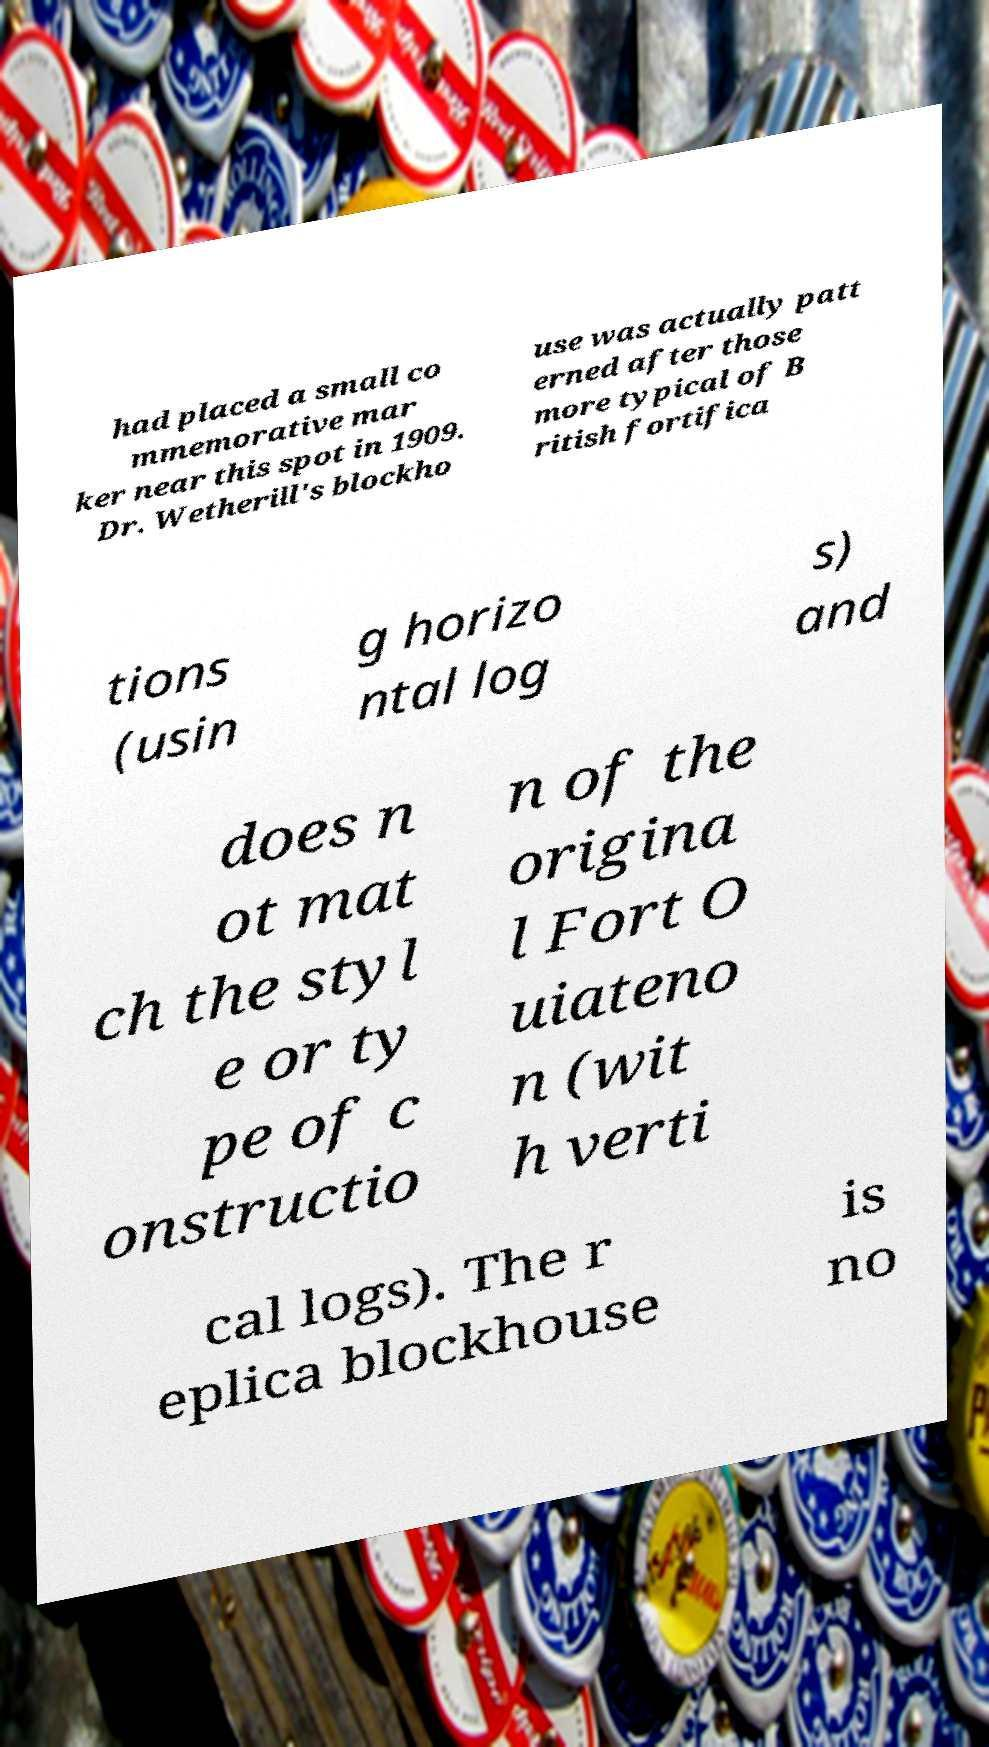Can you accurately transcribe the text from the provided image for me? had placed a small co mmemorative mar ker near this spot in 1909. Dr. Wetherill's blockho use was actually patt erned after those more typical of B ritish fortifica tions (usin g horizo ntal log s) and does n ot mat ch the styl e or ty pe of c onstructio n of the origina l Fort O uiateno n (wit h verti cal logs). The r eplica blockhouse is no 